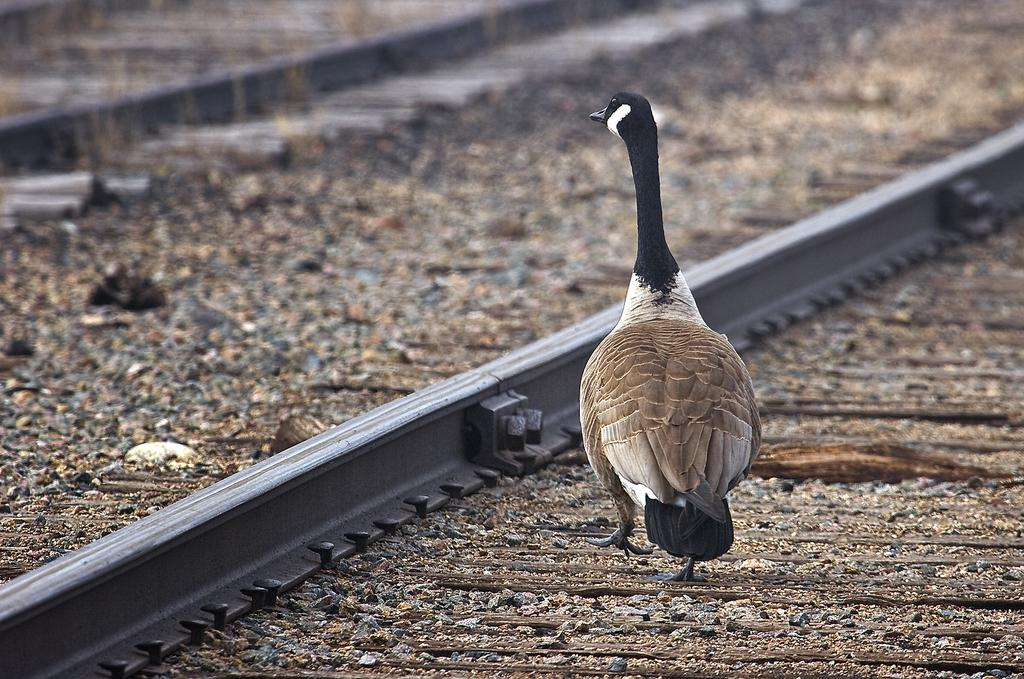What type of animal is in the image? There is a bird in the image. Where is the bird located in the image? The bird is standing on a railway track. What type of whip is the bird holding in the image? There is no whip present in the image; the bird is simply standing on the railway track. 